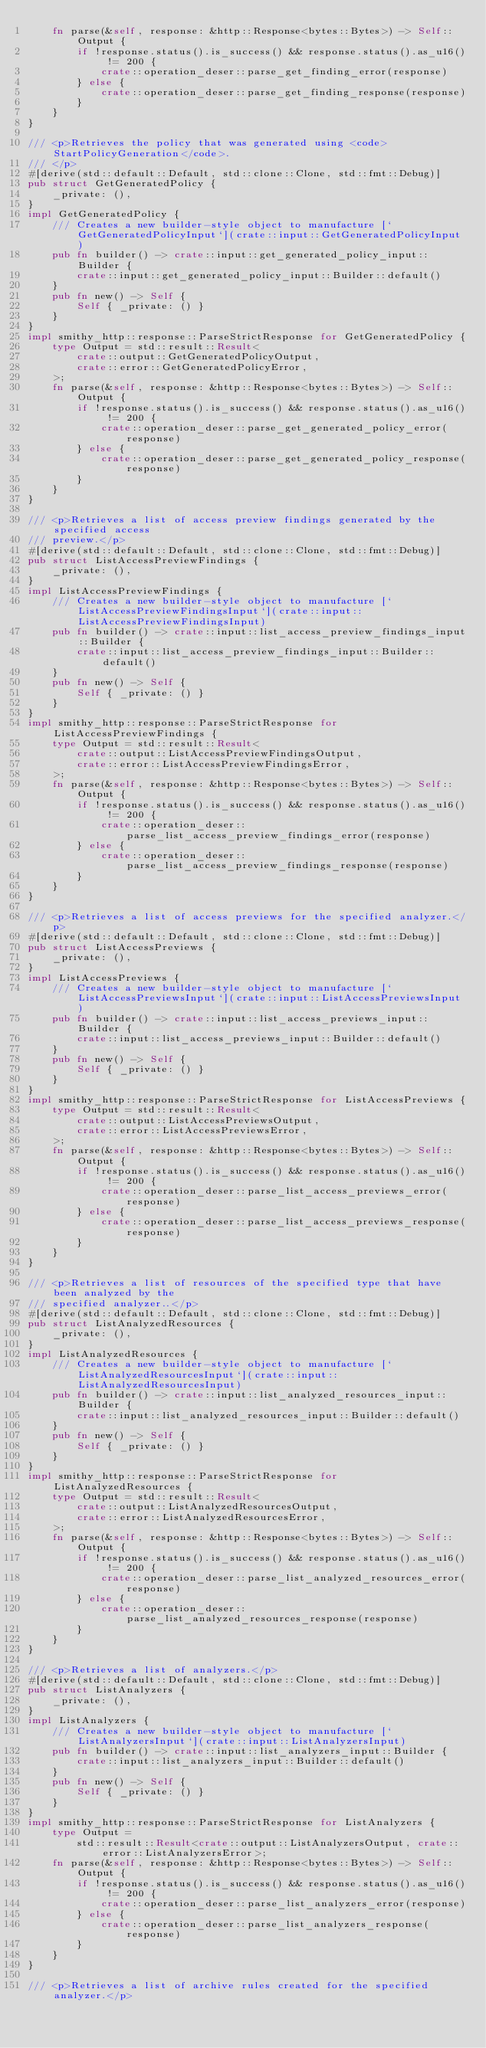Convert code to text. <code><loc_0><loc_0><loc_500><loc_500><_Rust_>    fn parse(&self, response: &http::Response<bytes::Bytes>) -> Self::Output {
        if !response.status().is_success() && response.status().as_u16() != 200 {
            crate::operation_deser::parse_get_finding_error(response)
        } else {
            crate::operation_deser::parse_get_finding_response(response)
        }
    }
}

/// <p>Retrieves the policy that was generated using <code>StartPolicyGeneration</code>.
/// </p>
#[derive(std::default::Default, std::clone::Clone, std::fmt::Debug)]
pub struct GetGeneratedPolicy {
    _private: (),
}
impl GetGeneratedPolicy {
    /// Creates a new builder-style object to manufacture [`GetGeneratedPolicyInput`](crate::input::GetGeneratedPolicyInput)
    pub fn builder() -> crate::input::get_generated_policy_input::Builder {
        crate::input::get_generated_policy_input::Builder::default()
    }
    pub fn new() -> Self {
        Self { _private: () }
    }
}
impl smithy_http::response::ParseStrictResponse for GetGeneratedPolicy {
    type Output = std::result::Result<
        crate::output::GetGeneratedPolicyOutput,
        crate::error::GetGeneratedPolicyError,
    >;
    fn parse(&self, response: &http::Response<bytes::Bytes>) -> Self::Output {
        if !response.status().is_success() && response.status().as_u16() != 200 {
            crate::operation_deser::parse_get_generated_policy_error(response)
        } else {
            crate::operation_deser::parse_get_generated_policy_response(response)
        }
    }
}

/// <p>Retrieves a list of access preview findings generated by the specified access
/// preview.</p>
#[derive(std::default::Default, std::clone::Clone, std::fmt::Debug)]
pub struct ListAccessPreviewFindings {
    _private: (),
}
impl ListAccessPreviewFindings {
    /// Creates a new builder-style object to manufacture [`ListAccessPreviewFindingsInput`](crate::input::ListAccessPreviewFindingsInput)
    pub fn builder() -> crate::input::list_access_preview_findings_input::Builder {
        crate::input::list_access_preview_findings_input::Builder::default()
    }
    pub fn new() -> Self {
        Self { _private: () }
    }
}
impl smithy_http::response::ParseStrictResponse for ListAccessPreviewFindings {
    type Output = std::result::Result<
        crate::output::ListAccessPreviewFindingsOutput,
        crate::error::ListAccessPreviewFindingsError,
    >;
    fn parse(&self, response: &http::Response<bytes::Bytes>) -> Self::Output {
        if !response.status().is_success() && response.status().as_u16() != 200 {
            crate::operation_deser::parse_list_access_preview_findings_error(response)
        } else {
            crate::operation_deser::parse_list_access_preview_findings_response(response)
        }
    }
}

/// <p>Retrieves a list of access previews for the specified analyzer.</p>
#[derive(std::default::Default, std::clone::Clone, std::fmt::Debug)]
pub struct ListAccessPreviews {
    _private: (),
}
impl ListAccessPreviews {
    /// Creates a new builder-style object to manufacture [`ListAccessPreviewsInput`](crate::input::ListAccessPreviewsInput)
    pub fn builder() -> crate::input::list_access_previews_input::Builder {
        crate::input::list_access_previews_input::Builder::default()
    }
    pub fn new() -> Self {
        Self { _private: () }
    }
}
impl smithy_http::response::ParseStrictResponse for ListAccessPreviews {
    type Output = std::result::Result<
        crate::output::ListAccessPreviewsOutput,
        crate::error::ListAccessPreviewsError,
    >;
    fn parse(&self, response: &http::Response<bytes::Bytes>) -> Self::Output {
        if !response.status().is_success() && response.status().as_u16() != 200 {
            crate::operation_deser::parse_list_access_previews_error(response)
        } else {
            crate::operation_deser::parse_list_access_previews_response(response)
        }
    }
}

/// <p>Retrieves a list of resources of the specified type that have been analyzed by the
/// specified analyzer..</p>
#[derive(std::default::Default, std::clone::Clone, std::fmt::Debug)]
pub struct ListAnalyzedResources {
    _private: (),
}
impl ListAnalyzedResources {
    /// Creates a new builder-style object to manufacture [`ListAnalyzedResourcesInput`](crate::input::ListAnalyzedResourcesInput)
    pub fn builder() -> crate::input::list_analyzed_resources_input::Builder {
        crate::input::list_analyzed_resources_input::Builder::default()
    }
    pub fn new() -> Self {
        Self { _private: () }
    }
}
impl smithy_http::response::ParseStrictResponse for ListAnalyzedResources {
    type Output = std::result::Result<
        crate::output::ListAnalyzedResourcesOutput,
        crate::error::ListAnalyzedResourcesError,
    >;
    fn parse(&self, response: &http::Response<bytes::Bytes>) -> Self::Output {
        if !response.status().is_success() && response.status().as_u16() != 200 {
            crate::operation_deser::parse_list_analyzed_resources_error(response)
        } else {
            crate::operation_deser::parse_list_analyzed_resources_response(response)
        }
    }
}

/// <p>Retrieves a list of analyzers.</p>
#[derive(std::default::Default, std::clone::Clone, std::fmt::Debug)]
pub struct ListAnalyzers {
    _private: (),
}
impl ListAnalyzers {
    /// Creates a new builder-style object to manufacture [`ListAnalyzersInput`](crate::input::ListAnalyzersInput)
    pub fn builder() -> crate::input::list_analyzers_input::Builder {
        crate::input::list_analyzers_input::Builder::default()
    }
    pub fn new() -> Self {
        Self { _private: () }
    }
}
impl smithy_http::response::ParseStrictResponse for ListAnalyzers {
    type Output =
        std::result::Result<crate::output::ListAnalyzersOutput, crate::error::ListAnalyzersError>;
    fn parse(&self, response: &http::Response<bytes::Bytes>) -> Self::Output {
        if !response.status().is_success() && response.status().as_u16() != 200 {
            crate::operation_deser::parse_list_analyzers_error(response)
        } else {
            crate::operation_deser::parse_list_analyzers_response(response)
        }
    }
}

/// <p>Retrieves a list of archive rules created for the specified analyzer.</p></code> 